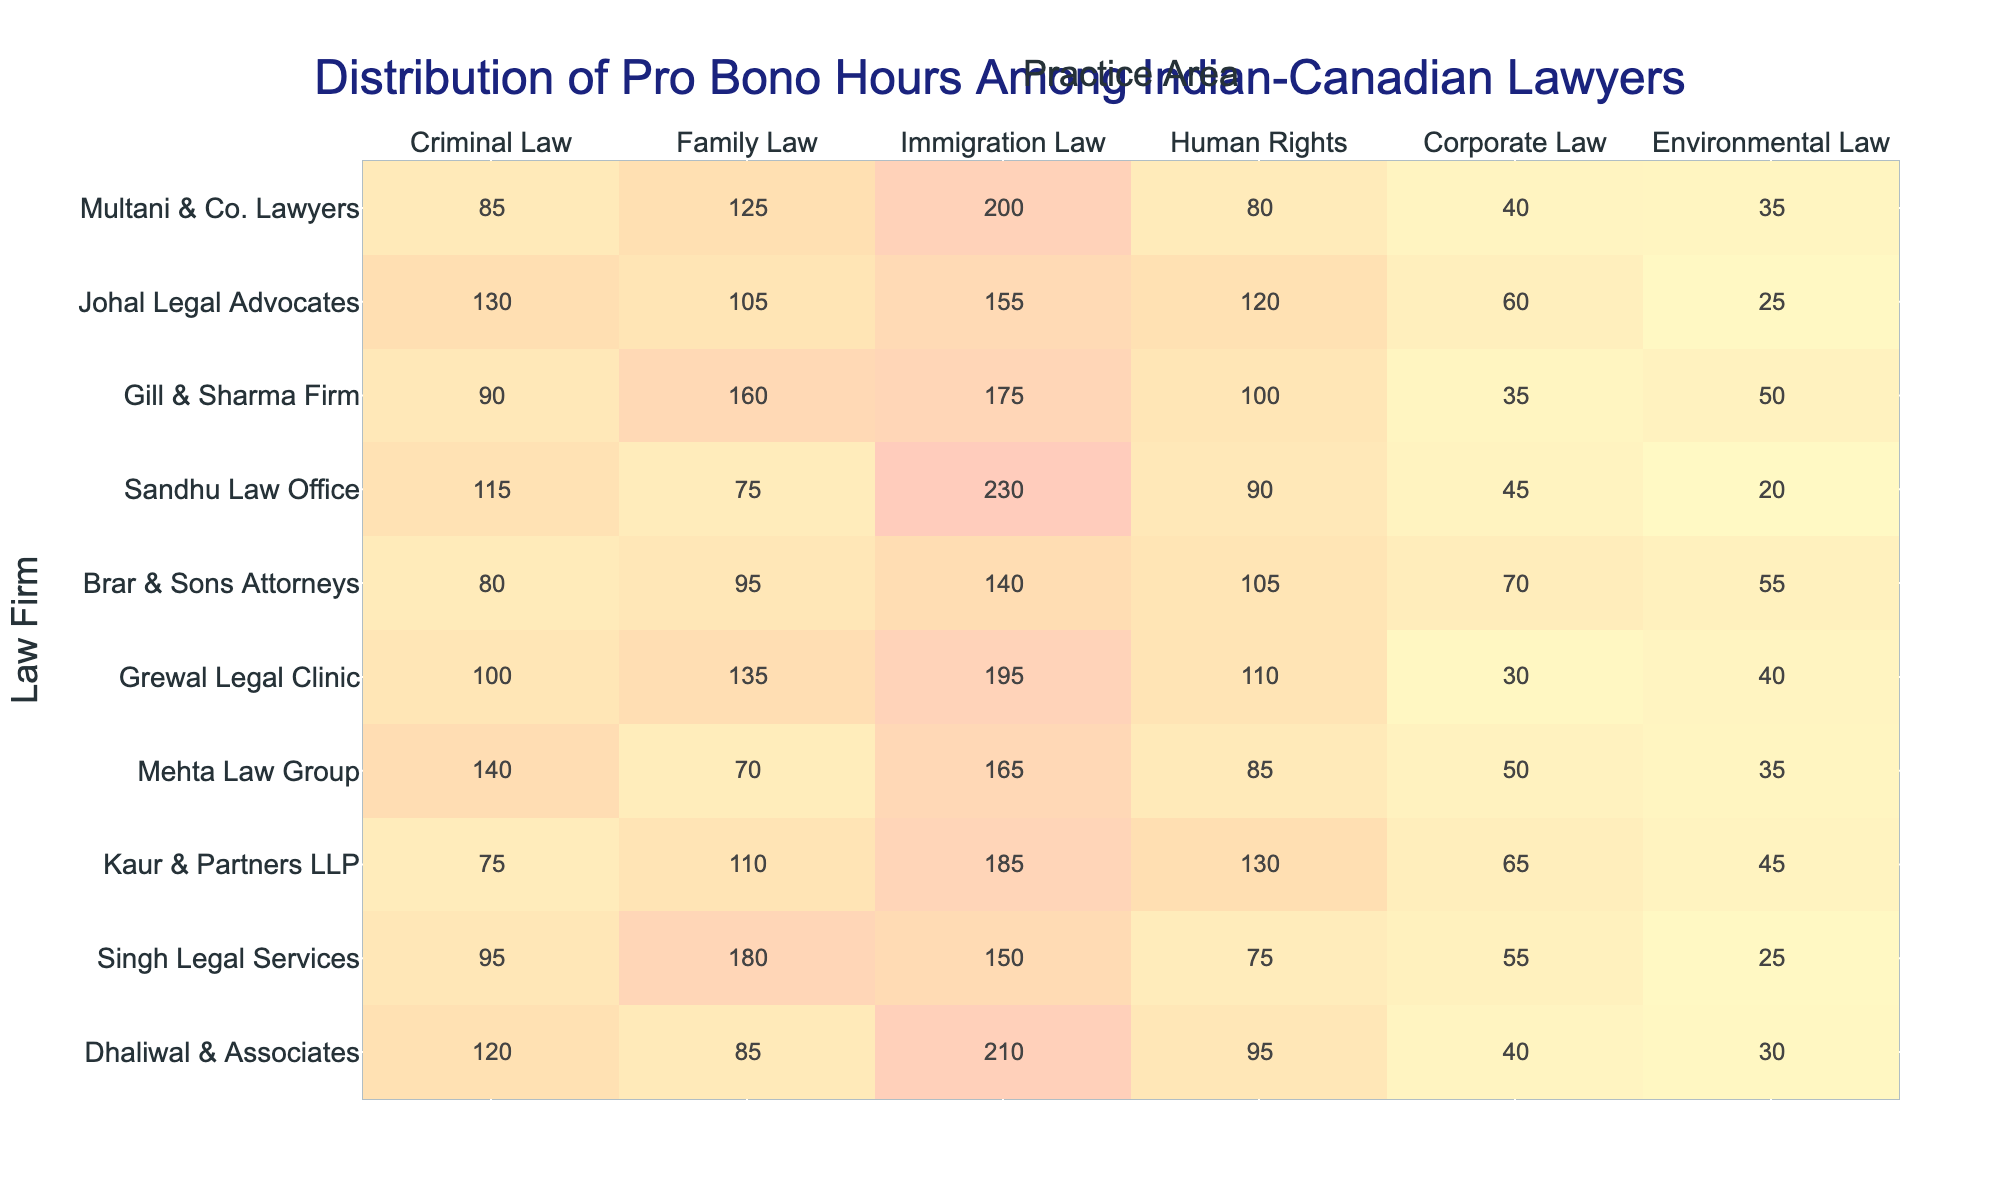What is the total number of pro bono hours contributed by Dhaliwal & Associates in Family Law? The table shows that Dhaliwal & Associates contributed 85 pro bono hours in Family Law.
Answer: 85 Which law firm contributed the most hours in Immigration Law? Looking at the Immigration Law column, Sandhu Law Office contributed 230 hours, which is the highest among all firms.
Answer: Sandhu Law Office What is the average number of pro bono hours across all law firms in Criminal Law? To find the average, we add the Criminal Law hours: 120 + 95 + 75 + 140 + 100 + 80 + 115 + 90 + 130 + 85 = 1,095. There are 10 firms, so the average is 1,095 / 10 = 109.5.
Answer: 109.5 Did any law firm contribute the same number of hours in Corporate Law? By checking the Corporate Law hours, we see that no two firms contributed the same amount, making this a false statement.
Answer: No What is the difference between the highest and lowest pro bono hours contributed in Human Rights? The highest is 130 hours by Kaur & Partners LLP and the lowest is 75 hours by Mehta Law Group. The difference is 130 - 75 = 55.
Answer: 55 Which practice area has the highest total hours when all law firms are combined? By summing the hours for each practice area: Criminal Law (1,095), Family Law (1,050), Immigration Law (1,975), Human Rights (1,025), Corporate Law (570), and Environmental Law (400). Immigration Law has the highest total with 1,975 hours.
Answer: Immigration Law How many pro bono hours does Gill & Sharma Firm contribute in total? Adding all categories for Gill & Sharma Firm: 90 + 160 + 175 + 100 + 35 + 50 = 610 pro bono hours in total.
Answer: 610 Which two law firms have the closest number of pro bono hours in Environmental Law? The Environmental Law hours for each firm showed that Brar & Sons Attorneys (55) and Sandhu Law Office (20) differ by 35, however, Multani & Co. Lawyers (35) is closer to Grewal Legal Clinic (40) with only 5-hour difference.
Answer: Multani & Co. Lawyers and Grewal Legal Clinic What is the total contribution of pro bono hours by Kaur & Partners LLP across all practice areas? Summing the hours for Kaur & Partners LLP: 75 + 110 + 185 + 130 + 65 + 45 = 610.
Answer: 610 Which law firm has the lowest hours in Environmental Law? Reviewing the Environmental Law column shows that Sandhu Law Office has the lowest contribution with 20 hours.
Answer: Sandhu Law Office 